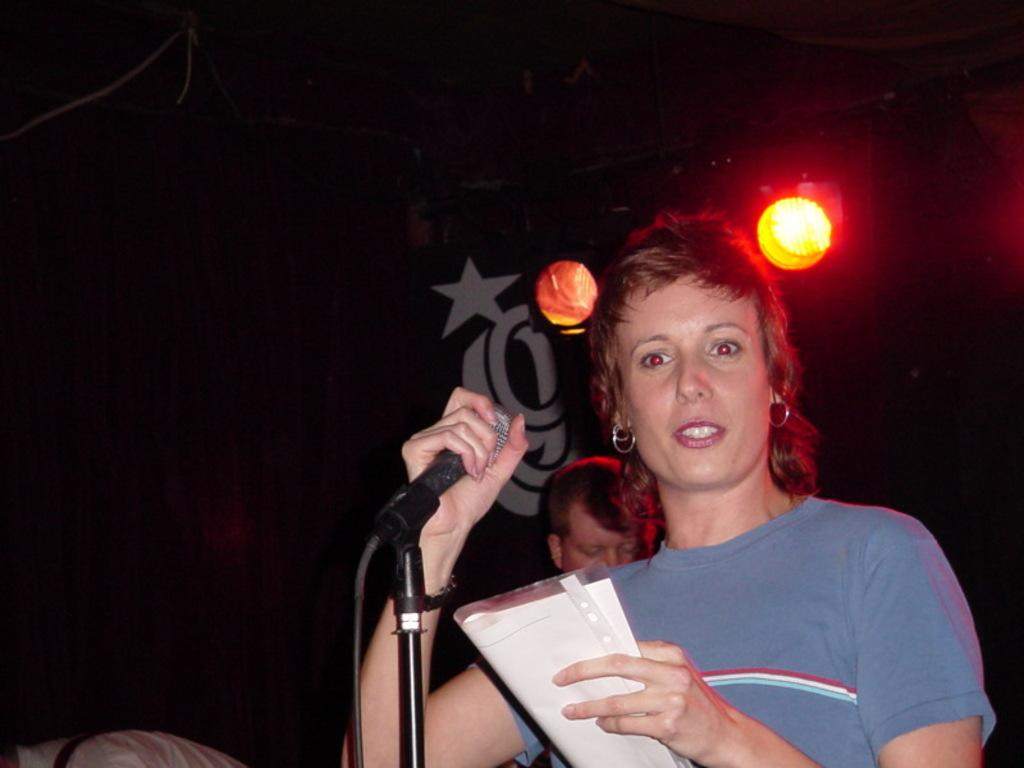What is the person in the image holding? The person is holding a microphone in the image. What else can be seen in the image besides the person with the microphone? There are papers and another person in the background of the image. What can be seen in the background of the image? There are lights visible in the background of the image. What type of sponge is being used by the person holding the microphone in the image? There is no sponge present in the image, and the person holding the microphone is not using any sponge. 